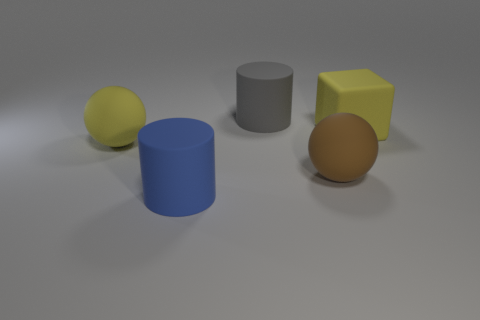There is a thing that is the same color as the large cube; what size is it?
Offer a terse response. Large. There is a blue matte thing that is the same shape as the large gray rubber thing; what size is it?
Offer a very short reply. Large. What number of blue matte things are in front of the large yellow thing that is to the right of the yellow sphere?
Provide a succinct answer. 1. Are there more large blue objects behind the yellow rubber ball than blue rubber cylinders behind the brown matte ball?
Provide a short and direct response. No. What is the gray thing made of?
Provide a succinct answer. Rubber. Are there any brown things of the same size as the gray thing?
Keep it short and to the point. Yes. There is a brown sphere that is the same size as the yellow sphere; what is it made of?
Make the answer very short. Rubber. What number of big balls are there?
Your answer should be compact. 2. There is a matte cylinder behind the big matte block; what size is it?
Offer a terse response. Large. Is the number of gray rubber cylinders that are in front of the big yellow sphere the same as the number of tiny yellow balls?
Provide a short and direct response. Yes. 